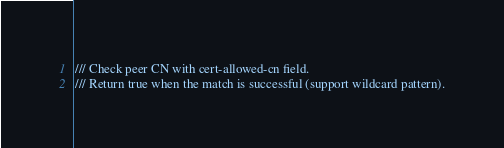<code> <loc_0><loc_0><loc_500><loc_500><_Rust_>/// Check peer CN with cert-allowed-cn field.
/// Return true when the match is successful (support wildcard pattern).</code> 